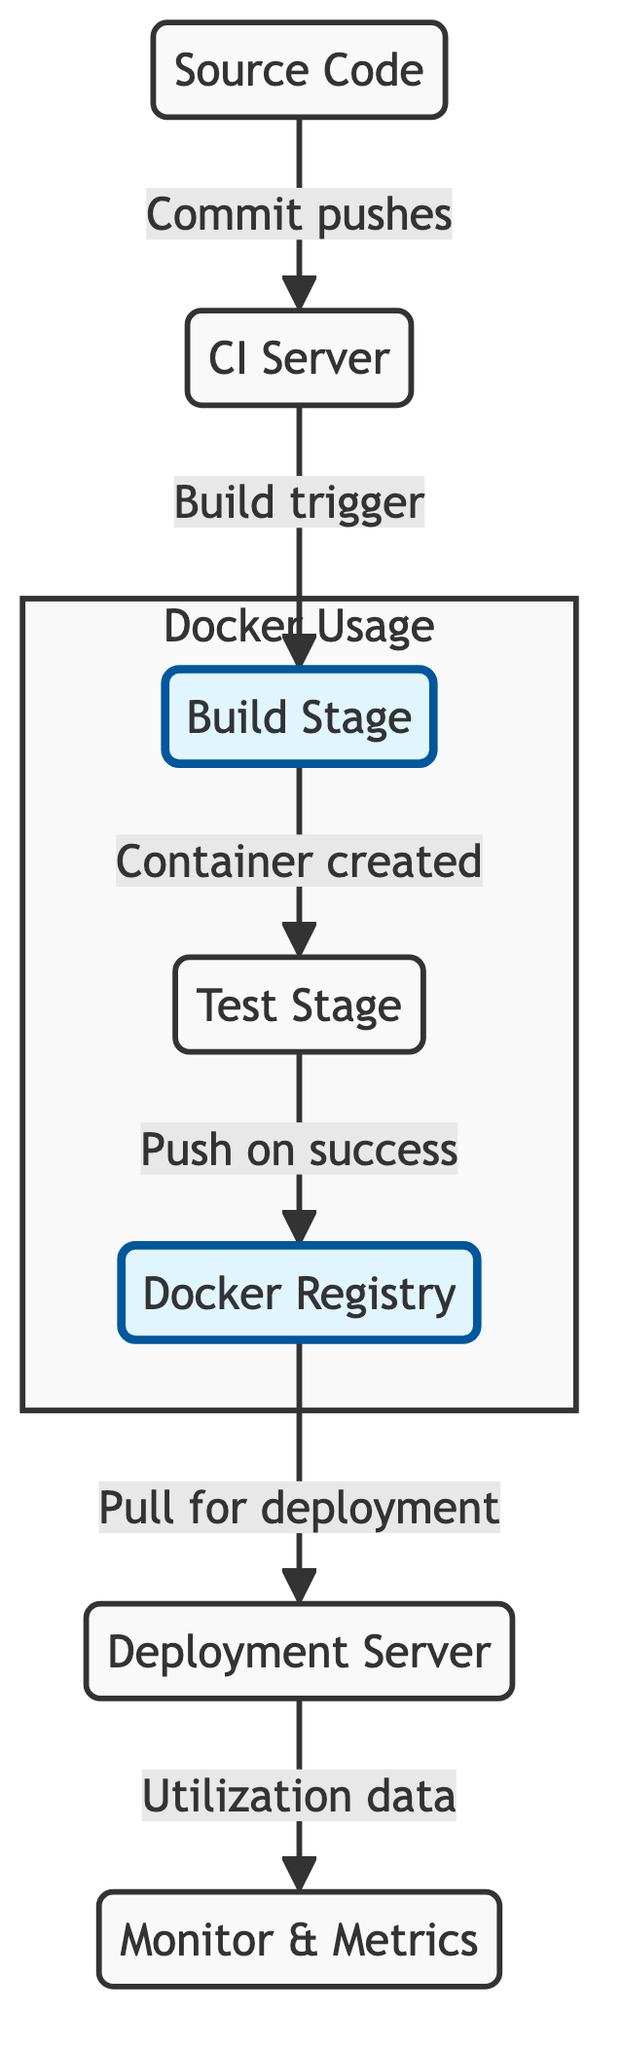What is the starting point of the CI/CD pipeline? The starting point of the CI/CD pipeline is the "Source Code" node, as it is the first one depicted in the flowchart.
Answer: Source Code How many main stages are highlighted in the Docker Usage subgraph? The subgraph highlights three main stages: Build Stage, Test Stage, and Docker Registry.
Answer: Three Which stage triggers the build process? The "CI Server" node triggers the build process, as indicated by the directed edge from "CI Server" to "Build Stage" labeled "Build trigger."
Answer: CI Server What happens after the Test Stage on success? After the Test Stage, if successful, the next step is to push the container image to the Docker Registry, as indicated by the label "Push on success."
Answer: Push to Docker Registry What is monitored after deployment? After deployment, the "Utilization data" is monitored and sent to the "Monitor & Metrics" node from the "Deployment Server."
Answer: Utilization data Which two nodes are highlighted to indicate significant Docker usage? The nodes "Build Stage" and "Docker Registry" are highlighted, indicating they are significant to Docker usage in the CI/CD pipeline.
Answer: Build Stage and Docker Registry In which direction does the flow go from the CI Server to the Build Stage? The flow goes from the "CI Server" to the "Build Stage," represented by a directed arrow indicating that the process moves forward.
Answer: Forward Which node utilizes the metrics collected from deployment? The "Monitor & Metrics" node utilizes the metrics collected from the deployment, as shown by the arrow originating from the "Deployment Server."
Answer: Monitor & Metrics 